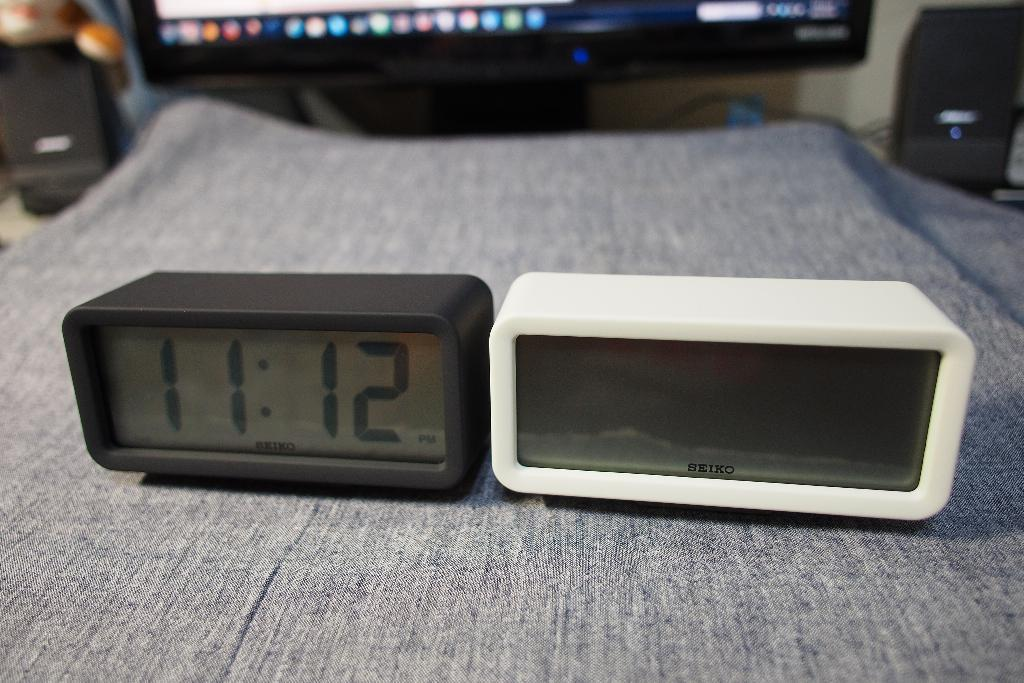<image>
Give a short and clear explanation of the subsequent image. the time is 11:12 on one of the alarms 